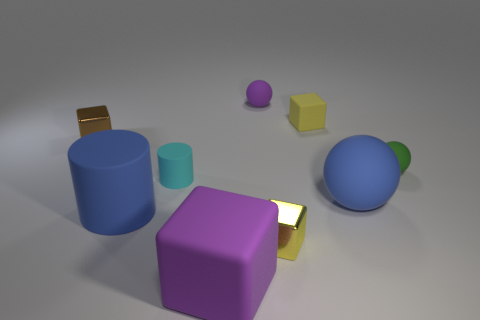Can you describe the relationship between the sizes and colors of the objects in the image? Certainly! The image shows a variety of geometric shapes with different sizes and colors. There's a large blue cylinder and a smaller cyan cylinder, indicating a contrast in size but a similarity in color hue. A large purple cube is complemented by a smaller yellow cube and a tiny purple sphere, showcasing both size contrast and color diversity. The presence of a golden cube offers a unique metallic texture in contrast to the others' matte finishes. 